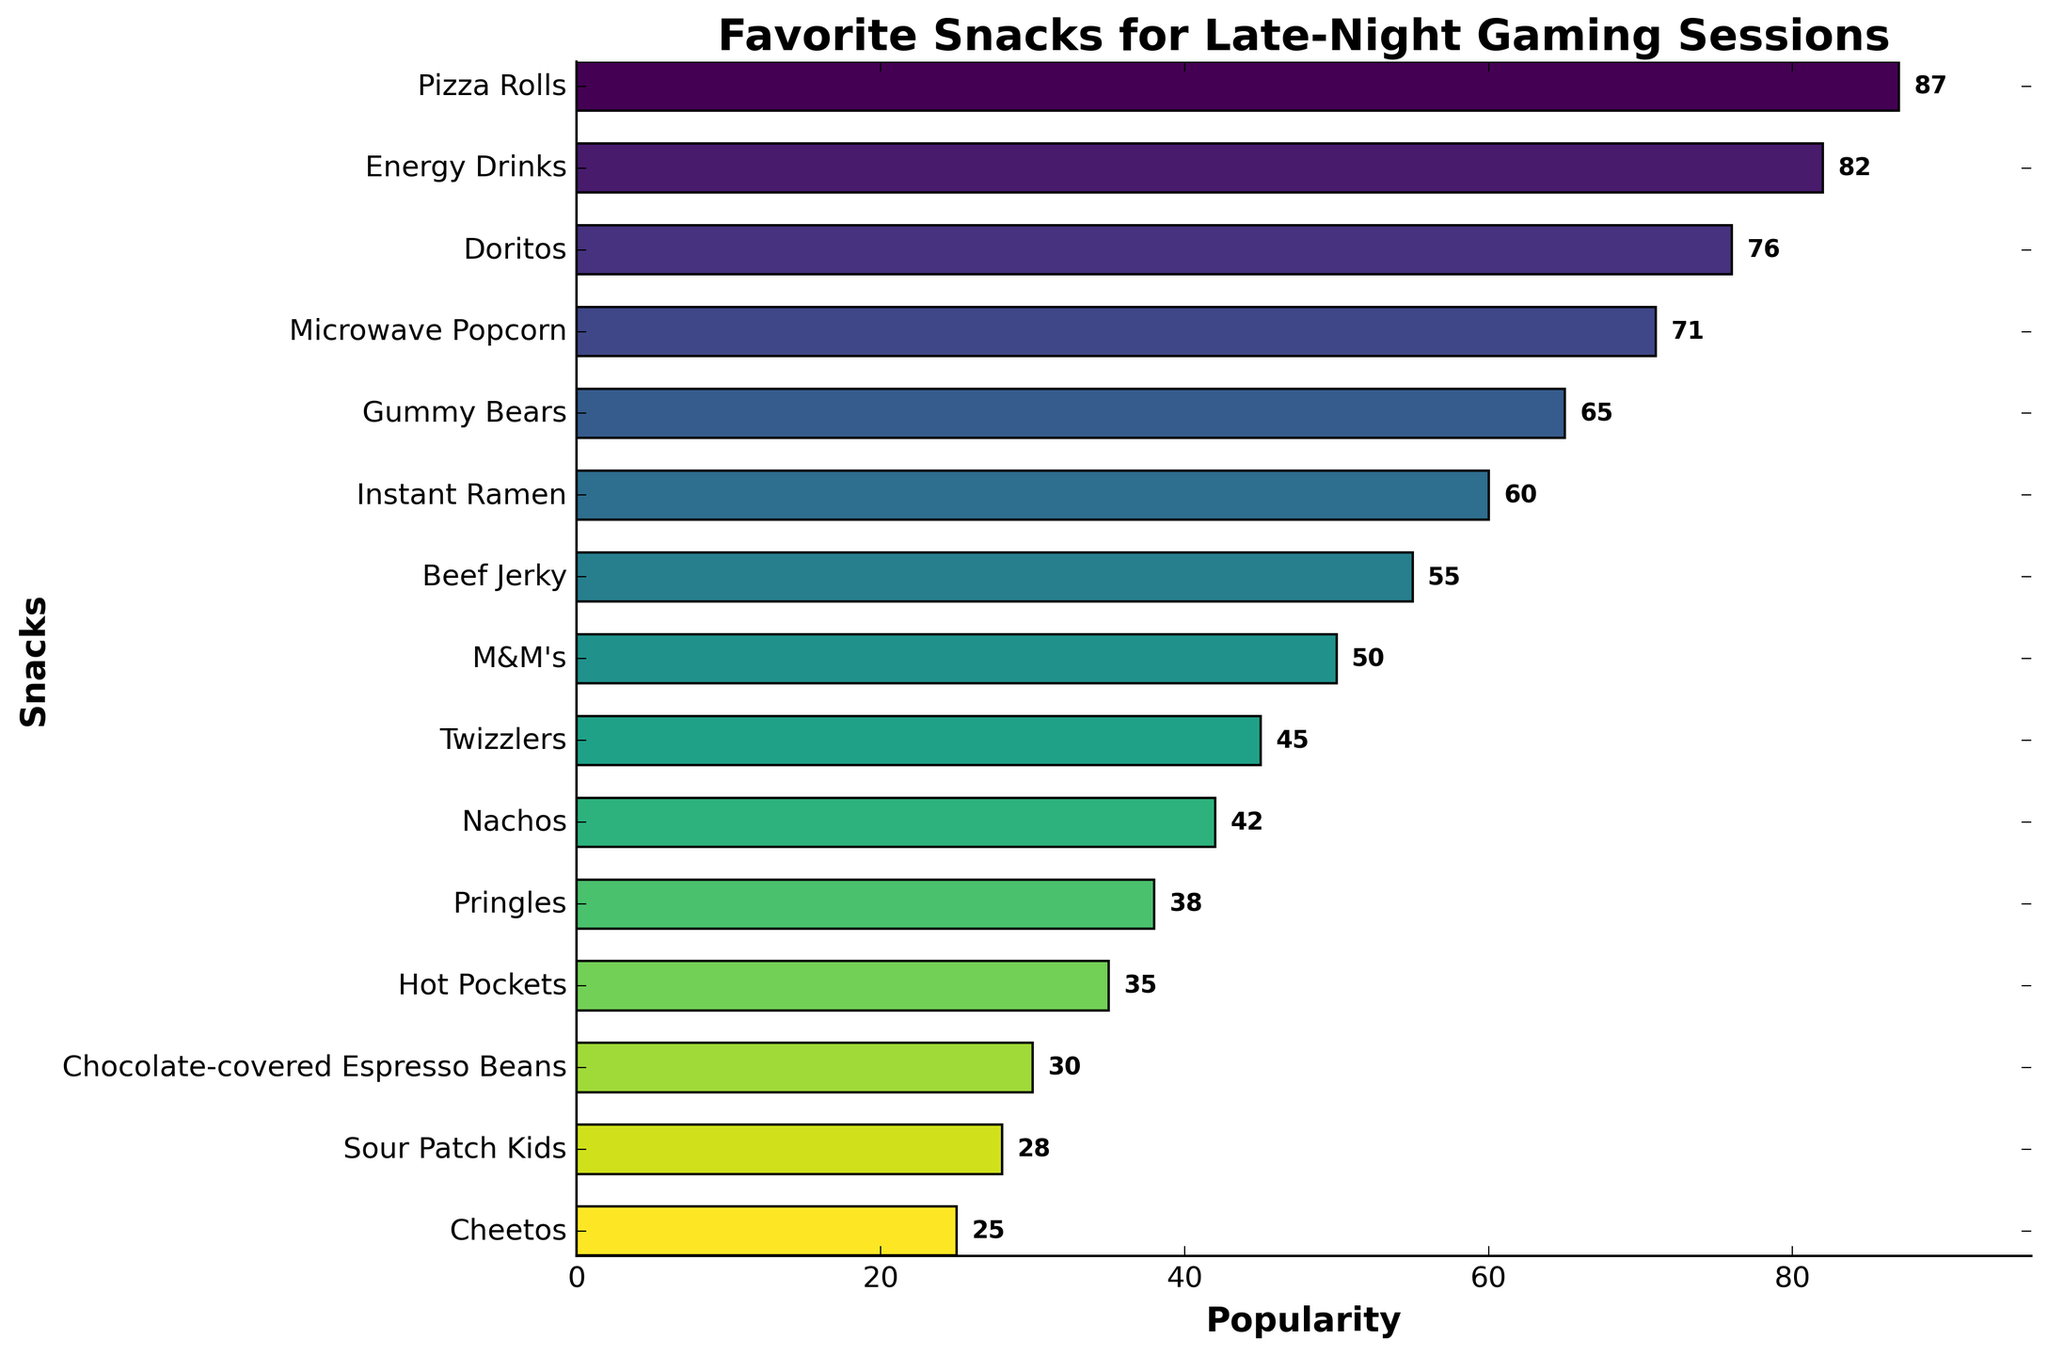Which snack is the most popular? The bar representing "Pizza Rolls" is the longest, indicating it has the highest popularity.
Answer: Pizza Rolls Which snack is the least popular? The bar representing "Cheetos" is the shortest, indicating it has the lowest popularity.
Answer: Cheetos What is the combined popularity of "Gummy Bears" and "Instant Ramen"? The popularity of "Gummy Bears" is 65, and "Instant Ramen" is 60. The combined popularity is 65 + 60.
Answer: 125 How much more popular are "Energy Drinks" compared to "Twizzlers"? The popularity of "Energy Drinks" is 82, and "Twizzlers" is 45. The difference is 82 - 45.
Answer: 37 Are "Doritos" more or less popular than "Microwave Popcorn"? The popularity of "Doritos" is 76, and "Microwave Popcorn" is 71. Comparing 76 and 71 shows that "Doritos" are more popular.
Answer: More Which snack ranks fourth in terms of popularity? Starting from the highest popularity, the fourth bar corresponds to "Microwave Popcorn."
Answer: Microwave Popcorn What is the average popularity of the top three most popular snacks? The top three snacks are "Pizza Rolls" (87), "Energy Drinks" (82), and "Doritos" (76). The average is (87 + 82 + 76) / 3.
Answer: 81.67 What is the difference in popularity between the highest and lowest popularity snacks? The highest popularity is 87 ("Pizza Rolls"), and the lowest is 25 ("Cheetos"). The difference is 87 - 25.
Answer: 62 How many snacks have a popularity greater than 50? Snacks with popularity greater than 50 are "Pizza Rolls," "Energy Drinks," "Doritos," "Microwave Popcorn," "Gummy Bears," and "Instant Ramen," totaling 6 snacks.
Answer: 6 Which snack has a popularity closest to the average of all snacks? To find the average: sum all snack popularity values and divide by the number of snacks (87 + 82 + 76 + 71 + 65 + 60 + 55 + 50 + 45 + 42 + 38 + 35 + 30 + 28 + 25) / 15 ≈ 52.07. "M&M's" has a popularity of 50, closest to the average.
Answer: M&M's 